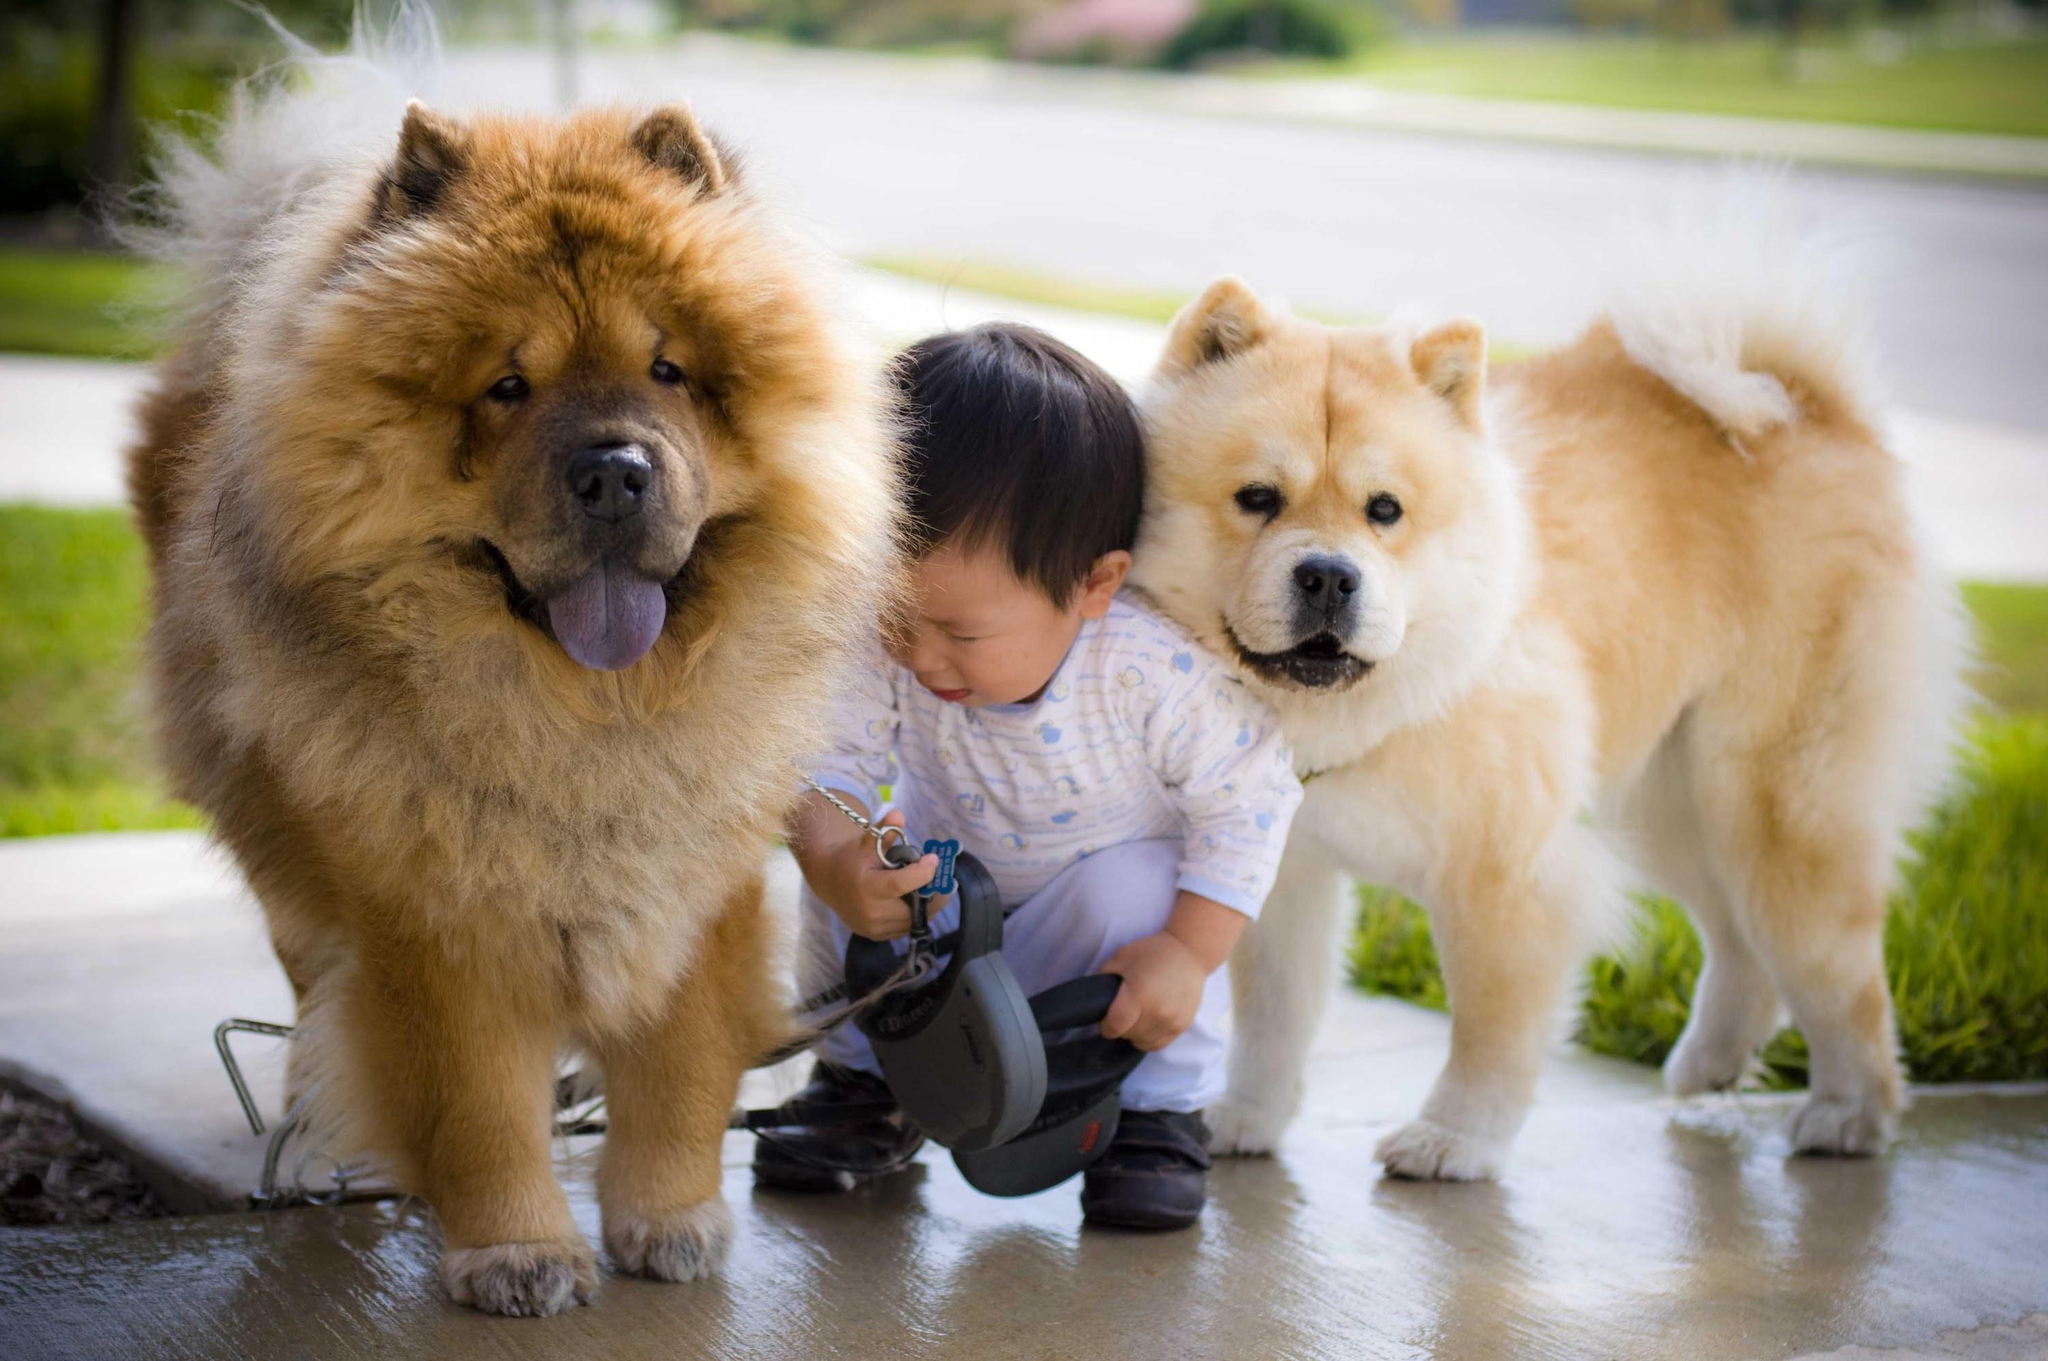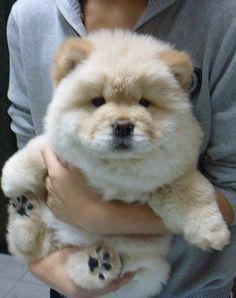The first image is the image on the left, the second image is the image on the right. For the images displayed, is the sentence "One of the images contains at least four dogs." factually correct? Answer yes or no. No. 